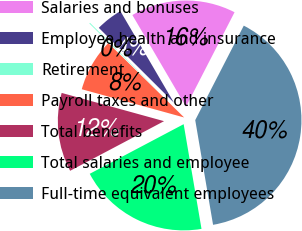Convert chart. <chart><loc_0><loc_0><loc_500><loc_500><pie_chart><fcel>Salaries and bonuses<fcel>Employee health and insurance<fcel>Retirement<fcel>Payroll taxes and other<fcel>Total benefits<fcel>Total salaries and employee<fcel>Full-time equivalent employees<nl><fcel>15.98%<fcel>4.1%<fcel>0.13%<fcel>8.06%<fcel>12.02%<fcel>19.95%<fcel>39.76%<nl></chart> 